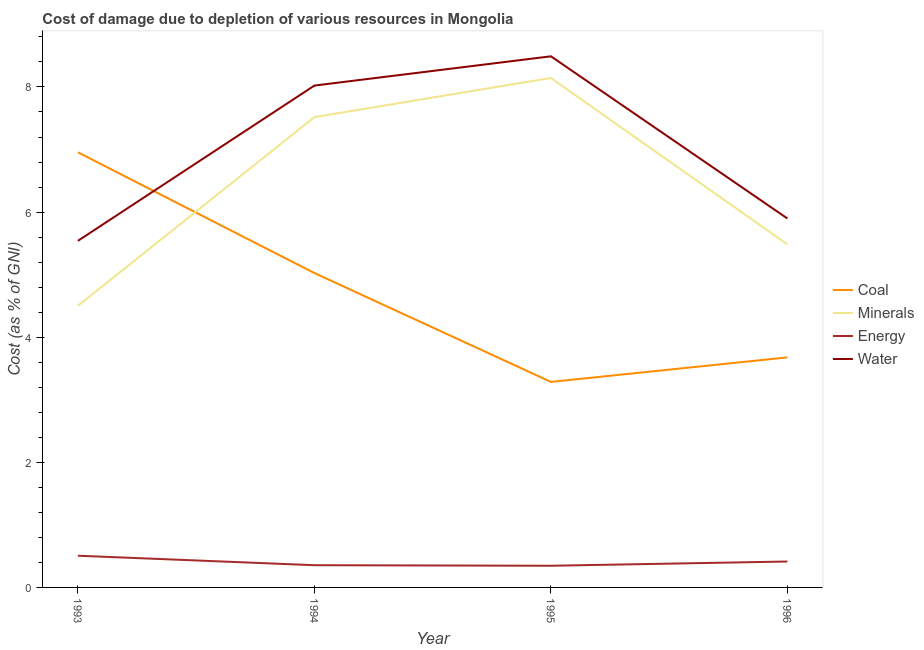How many different coloured lines are there?
Offer a very short reply. 4. Does the line corresponding to cost of damage due to depletion of minerals intersect with the line corresponding to cost of damage due to depletion of coal?
Make the answer very short. Yes. What is the cost of damage due to depletion of minerals in 1995?
Your answer should be compact. 8.14. Across all years, what is the maximum cost of damage due to depletion of minerals?
Your response must be concise. 8.14. Across all years, what is the minimum cost of damage due to depletion of minerals?
Ensure brevity in your answer.  4.5. In which year was the cost of damage due to depletion of water maximum?
Make the answer very short. 1995. What is the total cost of damage due to depletion of energy in the graph?
Keep it short and to the point. 1.62. What is the difference between the cost of damage due to depletion of minerals in 1993 and that in 1994?
Keep it short and to the point. -3.02. What is the difference between the cost of damage due to depletion of coal in 1996 and the cost of damage due to depletion of water in 1994?
Your response must be concise. -4.34. What is the average cost of damage due to depletion of minerals per year?
Your response must be concise. 6.41. In the year 1995, what is the difference between the cost of damage due to depletion of minerals and cost of damage due to depletion of energy?
Offer a very short reply. 7.8. What is the ratio of the cost of damage due to depletion of water in 1994 to that in 1995?
Offer a terse response. 0.94. Is the cost of damage due to depletion of coal in 1994 less than that in 1996?
Keep it short and to the point. No. Is the difference between the cost of damage due to depletion of energy in 1993 and 1995 greater than the difference between the cost of damage due to depletion of coal in 1993 and 1995?
Your response must be concise. No. What is the difference between the highest and the second highest cost of damage due to depletion of energy?
Keep it short and to the point. 0.09. What is the difference between the highest and the lowest cost of damage due to depletion of coal?
Keep it short and to the point. 3.67. In how many years, is the cost of damage due to depletion of minerals greater than the average cost of damage due to depletion of minerals taken over all years?
Ensure brevity in your answer.  2. Is it the case that in every year, the sum of the cost of damage due to depletion of coal and cost of damage due to depletion of minerals is greater than the cost of damage due to depletion of energy?
Provide a succinct answer. Yes. How many years are there in the graph?
Offer a very short reply. 4. What is the difference between two consecutive major ticks on the Y-axis?
Your answer should be very brief. 2. What is the title of the graph?
Keep it short and to the point. Cost of damage due to depletion of various resources in Mongolia . What is the label or title of the Y-axis?
Provide a short and direct response. Cost (as % of GNI). What is the Cost (as % of GNI) in Coal in 1993?
Your response must be concise. 6.96. What is the Cost (as % of GNI) in Minerals in 1993?
Offer a terse response. 4.5. What is the Cost (as % of GNI) in Energy in 1993?
Provide a short and direct response. 0.51. What is the Cost (as % of GNI) in Water in 1993?
Provide a succinct answer. 5.54. What is the Cost (as % of GNI) of Coal in 1994?
Offer a very short reply. 5.03. What is the Cost (as % of GNI) of Minerals in 1994?
Ensure brevity in your answer.  7.52. What is the Cost (as % of GNI) of Energy in 1994?
Offer a very short reply. 0.36. What is the Cost (as % of GNI) of Water in 1994?
Your response must be concise. 8.02. What is the Cost (as % of GNI) in Coal in 1995?
Your answer should be compact. 3.29. What is the Cost (as % of GNI) in Minerals in 1995?
Make the answer very short. 8.14. What is the Cost (as % of GNI) in Energy in 1995?
Ensure brevity in your answer.  0.35. What is the Cost (as % of GNI) in Water in 1995?
Your response must be concise. 8.49. What is the Cost (as % of GNI) in Coal in 1996?
Provide a succinct answer. 3.68. What is the Cost (as % of GNI) in Minerals in 1996?
Your answer should be compact. 5.48. What is the Cost (as % of GNI) of Energy in 1996?
Provide a succinct answer. 0.41. What is the Cost (as % of GNI) in Water in 1996?
Provide a succinct answer. 5.9. Across all years, what is the maximum Cost (as % of GNI) of Coal?
Give a very brief answer. 6.96. Across all years, what is the maximum Cost (as % of GNI) of Minerals?
Provide a succinct answer. 8.14. Across all years, what is the maximum Cost (as % of GNI) of Energy?
Keep it short and to the point. 0.51. Across all years, what is the maximum Cost (as % of GNI) in Water?
Offer a very short reply. 8.49. Across all years, what is the minimum Cost (as % of GNI) in Coal?
Offer a terse response. 3.29. Across all years, what is the minimum Cost (as % of GNI) in Minerals?
Your response must be concise. 4.5. Across all years, what is the minimum Cost (as % of GNI) in Energy?
Give a very brief answer. 0.35. Across all years, what is the minimum Cost (as % of GNI) in Water?
Provide a succinct answer. 5.54. What is the total Cost (as % of GNI) in Coal in the graph?
Provide a short and direct response. 18.94. What is the total Cost (as % of GNI) in Minerals in the graph?
Offer a terse response. 25.65. What is the total Cost (as % of GNI) of Energy in the graph?
Provide a succinct answer. 1.62. What is the total Cost (as % of GNI) of Water in the graph?
Offer a very short reply. 27.95. What is the difference between the Cost (as % of GNI) in Coal in 1993 and that in 1994?
Offer a very short reply. 1.93. What is the difference between the Cost (as % of GNI) of Minerals in 1993 and that in 1994?
Your answer should be compact. -3.02. What is the difference between the Cost (as % of GNI) in Energy in 1993 and that in 1994?
Give a very brief answer. 0.15. What is the difference between the Cost (as % of GNI) in Water in 1993 and that in 1994?
Provide a succinct answer. -2.48. What is the difference between the Cost (as % of GNI) in Coal in 1993 and that in 1995?
Ensure brevity in your answer.  3.67. What is the difference between the Cost (as % of GNI) of Minerals in 1993 and that in 1995?
Provide a short and direct response. -3.64. What is the difference between the Cost (as % of GNI) in Energy in 1993 and that in 1995?
Offer a very short reply. 0.16. What is the difference between the Cost (as % of GNI) of Water in 1993 and that in 1995?
Offer a very short reply. -2.95. What is the difference between the Cost (as % of GNI) in Coal in 1993 and that in 1996?
Your answer should be very brief. 3.28. What is the difference between the Cost (as % of GNI) in Minerals in 1993 and that in 1996?
Your answer should be very brief. -0.98. What is the difference between the Cost (as % of GNI) of Energy in 1993 and that in 1996?
Make the answer very short. 0.09. What is the difference between the Cost (as % of GNI) of Water in 1993 and that in 1996?
Keep it short and to the point. -0.36. What is the difference between the Cost (as % of GNI) in Coal in 1994 and that in 1995?
Offer a very short reply. 1.74. What is the difference between the Cost (as % of GNI) in Minerals in 1994 and that in 1995?
Provide a short and direct response. -0.63. What is the difference between the Cost (as % of GNI) in Energy in 1994 and that in 1995?
Offer a very short reply. 0.01. What is the difference between the Cost (as % of GNI) in Water in 1994 and that in 1995?
Make the answer very short. -0.47. What is the difference between the Cost (as % of GNI) in Coal in 1994 and that in 1996?
Ensure brevity in your answer.  1.35. What is the difference between the Cost (as % of GNI) in Minerals in 1994 and that in 1996?
Give a very brief answer. 2.03. What is the difference between the Cost (as % of GNI) in Energy in 1994 and that in 1996?
Your response must be concise. -0.06. What is the difference between the Cost (as % of GNI) of Water in 1994 and that in 1996?
Make the answer very short. 2.12. What is the difference between the Cost (as % of GNI) of Coal in 1995 and that in 1996?
Make the answer very short. -0.39. What is the difference between the Cost (as % of GNI) of Minerals in 1995 and that in 1996?
Ensure brevity in your answer.  2.66. What is the difference between the Cost (as % of GNI) of Energy in 1995 and that in 1996?
Provide a short and direct response. -0.07. What is the difference between the Cost (as % of GNI) of Water in 1995 and that in 1996?
Make the answer very short. 2.59. What is the difference between the Cost (as % of GNI) in Coal in 1993 and the Cost (as % of GNI) in Minerals in 1994?
Ensure brevity in your answer.  -0.56. What is the difference between the Cost (as % of GNI) of Coal in 1993 and the Cost (as % of GNI) of Energy in 1994?
Your response must be concise. 6.6. What is the difference between the Cost (as % of GNI) in Coal in 1993 and the Cost (as % of GNI) in Water in 1994?
Offer a terse response. -1.07. What is the difference between the Cost (as % of GNI) of Minerals in 1993 and the Cost (as % of GNI) of Energy in 1994?
Keep it short and to the point. 4.15. What is the difference between the Cost (as % of GNI) of Minerals in 1993 and the Cost (as % of GNI) of Water in 1994?
Offer a very short reply. -3.52. What is the difference between the Cost (as % of GNI) of Energy in 1993 and the Cost (as % of GNI) of Water in 1994?
Offer a very short reply. -7.52. What is the difference between the Cost (as % of GNI) of Coal in 1993 and the Cost (as % of GNI) of Minerals in 1995?
Offer a terse response. -1.19. What is the difference between the Cost (as % of GNI) of Coal in 1993 and the Cost (as % of GNI) of Energy in 1995?
Give a very brief answer. 6.61. What is the difference between the Cost (as % of GNI) in Coal in 1993 and the Cost (as % of GNI) in Water in 1995?
Ensure brevity in your answer.  -1.53. What is the difference between the Cost (as % of GNI) of Minerals in 1993 and the Cost (as % of GNI) of Energy in 1995?
Keep it short and to the point. 4.16. What is the difference between the Cost (as % of GNI) of Minerals in 1993 and the Cost (as % of GNI) of Water in 1995?
Ensure brevity in your answer.  -3.99. What is the difference between the Cost (as % of GNI) of Energy in 1993 and the Cost (as % of GNI) of Water in 1995?
Make the answer very short. -7.98. What is the difference between the Cost (as % of GNI) in Coal in 1993 and the Cost (as % of GNI) in Minerals in 1996?
Keep it short and to the point. 1.47. What is the difference between the Cost (as % of GNI) in Coal in 1993 and the Cost (as % of GNI) in Energy in 1996?
Give a very brief answer. 6.54. What is the difference between the Cost (as % of GNI) of Coal in 1993 and the Cost (as % of GNI) of Water in 1996?
Your answer should be compact. 1.06. What is the difference between the Cost (as % of GNI) of Minerals in 1993 and the Cost (as % of GNI) of Energy in 1996?
Your answer should be compact. 4.09. What is the difference between the Cost (as % of GNI) of Minerals in 1993 and the Cost (as % of GNI) of Water in 1996?
Keep it short and to the point. -1.4. What is the difference between the Cost (as % of GNI) of Energy in 1993 and the Cost (as % of GNI) of Water in 1996?
Provide a succinct answer. -5.39. What is the difference between the Cost (as % of GNI) in Coal in 1994 and the Cost (as % of GNI) in Minerals in 1995?
Provide a short and direct response. -3.12. What is the difference between the Cost (as % of GNI) of Coal in 1994 and the Cost (as % of GNI) of Energy in 1995?
Offer a terse response. 4.68. What is the difference between the Cost (as % of GNI) of Coal in 1994 and the Cost (as % of GNI) of Water in 1995?
Offer a terse response. -3.46. What is the difference between the Cost (as % of GNI) in Minerals in 1994 and the Cost (as % of GNI) in Energy in 1995?
Offer a terse response. 7.17. What is the difference between the Cost (as % of GNI) in Minerals in 1994 and the Cost (as % of GNI) in Water in 1995?
Your answer should be compact. -0.97. What is the difference between the Cost (as % of GNI) of Energy in 1994 and the Cost (as % of GNI) of Water in 1995?
Your answer should be very brief. -8.13. What is the difference between the Cost (as % of GNI) of Coal in 1994 and the Cost (as % of GNI) of Minerals in 1996?
Offer a terse response. -0.46. What is the difference between the Cost (as % of GNI) of Coal in 1994 and the Cost (as % of GNI) of Energy in 1996?
Provide a short and direct response. 4.61. What is the difference between the Cost (as % of GNI) of Coal in 1994 and the Cost (as % of GNI) of Water in 1996?
Your response must be concise. -0.87. What is the difference between the Cost (as % of GNI) of Minerals in 1994 and the Cost (as % of GNI) of Energy in 1996?
Your answer should be very brief. 7.1. What is the difference between the Cost (as % of GNI) in Minerals in 1994 and the Cost (as % of GNI) in Water in 1996?
Give a very brief answer. 1.62. What is the difference between the Cost (as % of GNI) of Energy in 1994 and the Cost (as % of GNI) of Water in 1996?
Offer a very short reply. -5.54. What is the difference between the Cost (as % of GNI) of Coal in 1995 and the Cost (as % of GNI) of Minerals in 1996?
Ensure brevity in your answer.  -2.2. What is the difference between the Cost (as % of GNI) of Coal in 1995 and the Cost (as % of GNI) of Energy in 1996?
Give a very brief answer. 2.87. What is the difference between the Cost (as % of GNI) in Coal in 1995 and the Cost (as % of GNI) in Water in 1996?
Ensure brevity in your answer.  -2.61. What is the difference between the Cost (as % of GNI) of Minerals in 1995 and the Cost (as % of GNI) of Energy in 1996?
Keep it short and to the point. 7.73. What is the difference between the Cost (as % of GNI) of Minerals in 1995 and the Cost (as % of GNI) of Water in 1996?
Keep it short and to the point. 2.25. What is the difference between the Cost (as % of GNI) in Energy in 1995 and the Cost (as % of GNI) in Water in 1996?
Your answer should be compact. -5.55. What is the average Cost (as % of GNI) of Coal per year?
Offer a terse response. 4.74. What is the average Cost (as % of GNI) in Minerals per year?
Make the answer very short. 6.41. What is the average Cost (as % of GNI) of Energy per year?
Offer a terse response. 0.41. What is the average Cost (as % of GNI) in Water per year?
Your response must be concise. 6.99. In the year 1993, what is the difference between the Cost (as % of GNI) in Coal and Cost (as % of GNI) in Minerals?
Your response must be concise. 2.45. In the year 1993, what is the difference between the Cost (as % of GNI) of Coal and Cost (as % of GNI) of Energy?
Give a very brief answer. 6.45. In the year 1993, what is the difference between the Cost (as % of GNI) in Coal and Cost (as % of GNI) in Water?
Keep it short and to the point. 1.42. In the year 1993, what is the difference between the Cost (as % of GNI) of Minerals and Cost (as % of GNI) of Energy?
Provide a short and direct response. 4. In the year 1993, what is the difference between the Cost (as % of GNI) of Minerals and Cost (as % of GNI) of Water?
Provide a short and direct response. -1.04. In the year 1993, what is the difference between the Cost (as % of GNI) in Energy and Cost (as % of GNI) in Water?
Ensure brevity in your answer.  -5.03. In the year 1994, what is the difference between the Cost (as % of GNI) in Coal and Cost (as % of GNI) in Minerals?
Keep it short and to the point. -2.49. In the year 1994, what is the difference between the Cost (as % of GNI) of Coal and Cost (as % of GNI) of Energy?
Your response must be concise. 4.67. In the year 1994, what is the difference between the Cost (as % of GNI) in Coal and Cost (as % of GNI) in Water?
Offer a very short reply. -3. In the year 1994, what is the difference between the Cost (as % of GNI) in Minerals and Cost (as % of GNI) in Energy?
Your answer should be compact. 7.16. In the year 1994, what is the difference between the Cost (as % of GNI) of Minerals and Cost (as % of GNI) of Water?
Give a very brief answer. -0.5. In the year 1994, what is the difference between the Cost (as % of GNI) in Energy and Cost (as % of GNI) in Water?
Ensure brevity in your answer.  -7.67. In the year 1995, what is the difference between the Cost (as % of GNI) in Coal and Cost (as % of GNI) in Minerals?
Offer a terse response. -4.86. In the year 1995, what is the difference between the Cost (as % of GNI) in Coal and Cost (as % of GNI) in Energy?
Make the answer very short. 2.94. In the year 1995, what is the difference between the Cost (as % of GNI) in Coal and Cost (as % of GNI) in Water?
Provide a succinct answer. -5.2. In the year 1995, what is the difference between the Cost (as % of GNI) in Minerals and Cost (as % of GNI) in Energy?
Your answer should be compact. 7.8. In the year 1995, what is the difference between the Cost (as % of GNI) in Minerals and Cost (as % of GNI) in Water?
Offer a terse response. -0.35. In the year 1995, what is the difference between the Cost (as % of GNI) of Energy and Cost (as % of GNI) of Water?
Offer a very short reply. -8.14. In the year 1996, what is the difference between the Cost (as % of GNI) of Coal and Cost (as % of GNI) of Minerals?
Offer a terse response. -1.81. In the year 1996, what is the difference between the Cost (as % of GNI) of Coal and Cost (as % of GNI) of Energy?
Offer a terse response. 3.26. In the year 1996, what is the difference between the Cost (as % of GNI) of Coal and Cost (as % of GNI) of Water?
Offer a very short reply. -2.22. In the year 1996, what is the difference between the Cost (as % of GNI) of Minerals and Cost (as % of GNI) of Energy?
Your response must be concise. 5.07. In the year 1996, what is the difference between the Cost (as % of GNI) of Minerals and Cost (as % of GNI) of Water?
Offer a very short reply. -0.41. In the year 1996, what is the difference between the Cost (as % of GNI) in Energy and Cost (as % of GNI) in Water?
Your response must be concise. -5.48. What is the ratio of the Cost (as % of GNI) of Coal in 1993 to that in 1994?
Ensure brevity in your answer.  1.38. What is the ratio of the Cost (as % of GNI) of Minerals in 1993 to that in 1994?
Your response must be concise. 0.6. What is the ratio of the Cost (as % of GNI) in Energy in 1993 to that in 1994?
Ensure brevity in your answer.  1.43. What is the ratio of the Cost (as % of GNI) of Water in 1993 to that in 1994?
Keep it short and to the point. 0.69. What is the ratio of the Cost (as % of GNI) in Coal in 1993 to that in 1995?
Give a very brief answer. 2.12. What is the ratio of the Cost (as % of GNI) of Minerals in 1993 to that in 1995?
Give a very brief answer. 0.55. What is the ratio of the Cost (as % of GNI) in Energy in 1993 to that in 1995?
Offer a terse response. 1.46. What is the ratio of the Cost (as % of GNI) in Water in 1993 to that in 1995?
Provide a succinct answer. 0.65. What is the ratio of the Cost (as % of GNI) in Coal in 1993 to that in 1996?
Keep it short and to the point. 1.89. What is the ratio of the Cost (as % of GNI) of Minerals in 1993 to that in 1996?
Offer a terse response. 0.82. What is the ratio of the Cost (as % of GNI) of Energy in 1993 to that in 1996?
Your answer should be compact. 1.22. What is the ratio of the Cost (as % of GNI) in Water in 1993 to that in 1996?
Your answer should be very brief. 0.94. What is the ratio of the Cost (as % of GNI) of Coal in 1994 to that in 1995?
Your response must be concise. 1.53. What is the ratio of the Cost (as % of GNI) in Minerals in 1994 to that in 1995?
Your answer should be very brief. 0.92. What is the ratio of the Cost (as % of GNI) of Energy in 1994 to that in 1995?
Keep it short and to the point. 1.02. What is the ratio of the Cost (as % of GNI) in Water in 1994 to that in 1995?
Offer a terse response. 0.94. What is the ratio of the Cost (as % of GNI) in Coal in 1994 to that in 1996?
Provide a succinct answer. 1.37. What is the ratio of the Cost (as % of GNI) of Minerals in 1994 to that in 1996?
Your response must be concise. 1.37. What is the ratio of the Cost (as % of GNI) in Energy in 1994 to that in 1996?
Keep it short and to the point. 0.86. What is the ratio of the Cost (as % of GNI) in Water in 1994 to that in 1996?
Ensure brevity in your answer.  1.36. What is the ratio of the Cost (as % of GNI) of Coal in 1995 to that in 1996?
Make the answer very short. 0.89. What is the ratio of the Cost (as % of GNI) in Minerals in 1995 to that in 1996?
Offer a terse response. 1.49. What is the ratio of the Cost (as % of GNI) in Energy in 1995 to that in 1996?
Make the answer very short. 0.84. What is the ratio of the Cost (as % of GNI) in Water in 1995 to that in 1996?
Your response must be concise. 1.44. What is the difference between the highest and the second highest Cost (as % of GNI) in Coal?
Your response must be concise. 1.93. What is the difference between the highest and the second highest Cost (as % of GNI) of Minerals?
Offer a very short reply. 0.63. What is the difference between the highest and the second highest Cost (as % of GNI) in Energy?
Offer a very short reply. 0.09. What is the difference between the highest and the second highest Cost (as % of GNI) of Water?
Make the answer very short. 0.47. What is the difference between the highest and the lowest Cost (as % of GNI) of Coal?
Ensure brevity in your answer.  3.67. What is the difference between the highest and the lowest Cost (as % of GNI) of Minerals?
Ensure brevity in your answer.  3.64. What is the difference between the highest and the lowest Cost (as % of GNI) of Energy?
Your response must be concise. 0.16. What is the difference between the highest and the lowest Cost (as % of GNI) of Water?
Give a very brief answer. 2.95. 